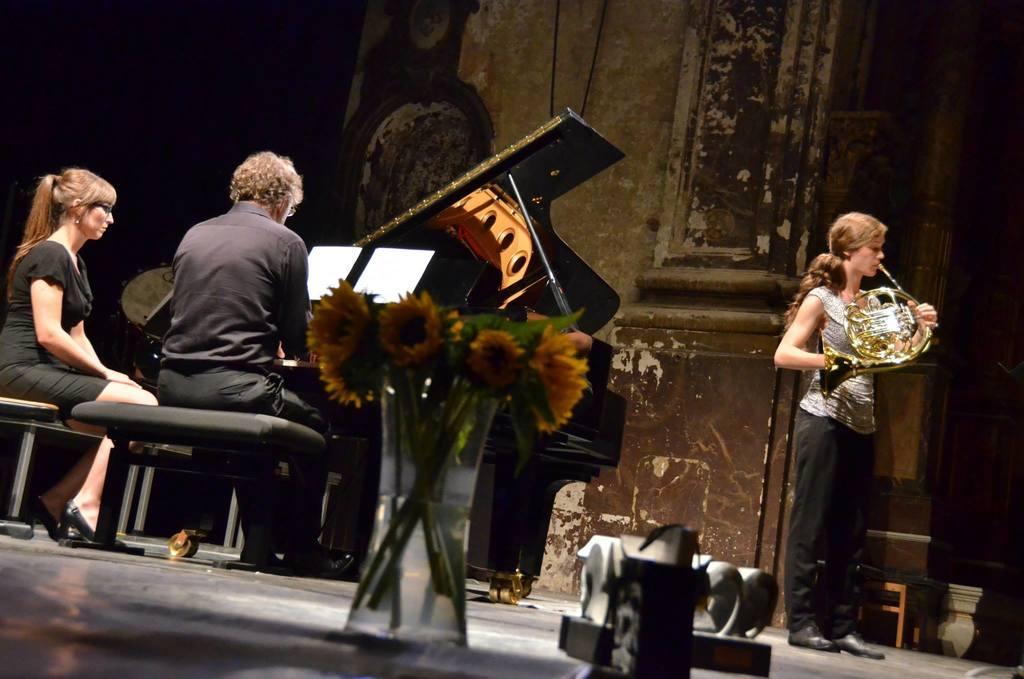In one or two sentences, can you explain what this image depicts? In the image we can see two people sitting and one is standing, they are wearing clothes and shoes. Here we can see musical instruments, flowers and the floor. Here we can see the papers, chair and the wall. 